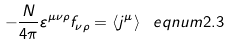Convert formula to latex. <formula><loc_0><loc_0><loc_500><loc_500>- \frac { N } { 4 \pi } \varepsilon ^ { \mu \nu \rho } f _ { \nu \rho } = \left \langle j ^ { \mu } \right \rangle \ e q n u m { 2 . 3 }</formula> 